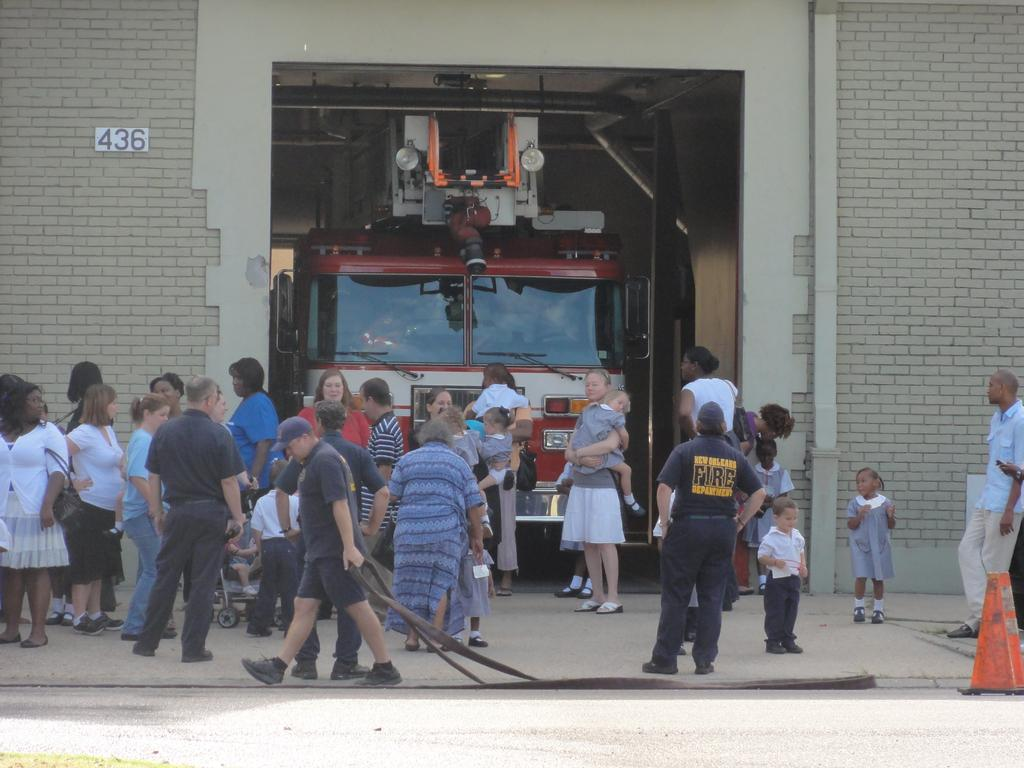What is happening in the image? There are people on the road in the image. What can be seen in the background of the image? There is a wall and a vehicle in the background of the image. How many icicles are hanging from the wall in the image? There are no icicles present in the image; the wall is not covered in ice. What type of pail is being used by the people on the road in the image? There is no pail visible in the image; the people are not carrying any pails. 